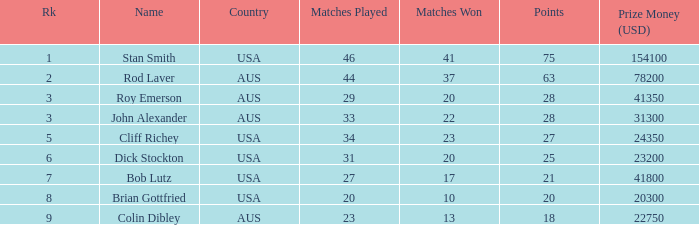How many us dollars did bob lutz earn in prize money? 41800.0. Write the full table. {'header': ['Rk', 'Name', 'Country', 'Matches Played', 'Matches Won', 'Points', 'Prize Money (USD)'], 'rows': [['1', 'Stan Smith', 'USA', '46', '41', '75', '154100'], ['2', 'Rod Laver', 'AUS', '44', '37', '63', '78200'], ['3', 'Roy Emerson', 'AUS', '29', '20', '28', '41350'], ['3', 'John Alexander', 'AUS', '33', '22', '28', '31300'], ['5', 'Cliff Richey', 'USA', '34', '23', '27', '24350'], ['6', 'Dick Stockton', 'USA', '31', '20', '25', '23200'], ['7', 'Bob Lutz', 'USA', '27', '17', '21', '41800'], ['8', 'Brian Gottfried', 'USA', '20', '10', '20', '20300'], ['9', 'Colin Dibley', 'AUS', '23', '13', '18', '22750']]} 